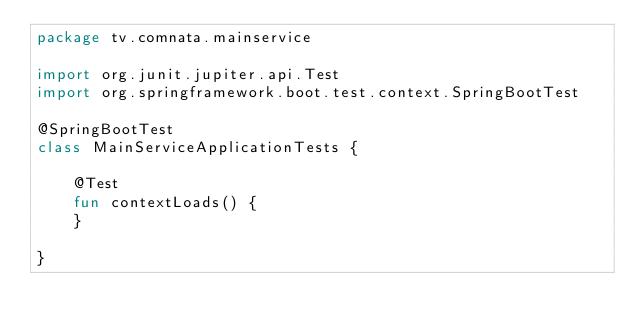<code> <loc_0><loc_0><loc_500><loc_500><_Kotlin_>package tv.comnata.mainservice

import org.junit.jupiter.api.Test
import org.springframework.boot.test.context.SpringBootTest

@SpringBootTest
class MainServiceApplicationTests {

    @Test
    fun contextLoads() {
    }

}
</code> 